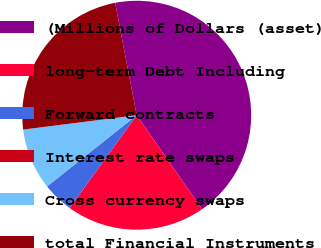<chart> <loc_0><loc_0><loc_500><loc_500><pie_chart><fcel>(Millions of Dollars (asset)<fcel>long-term Debt Including<fcel>Forward contracts<fcel>Interest rate swaps<fcel>Cross currency swaps<fcel>total Financial Instruments<nl><fcel>43.34%<fcel>19.65%<fcel>4.34%<fcel>0.01%<fcel>8.68%<fcel>23.98%<nl></chart> 